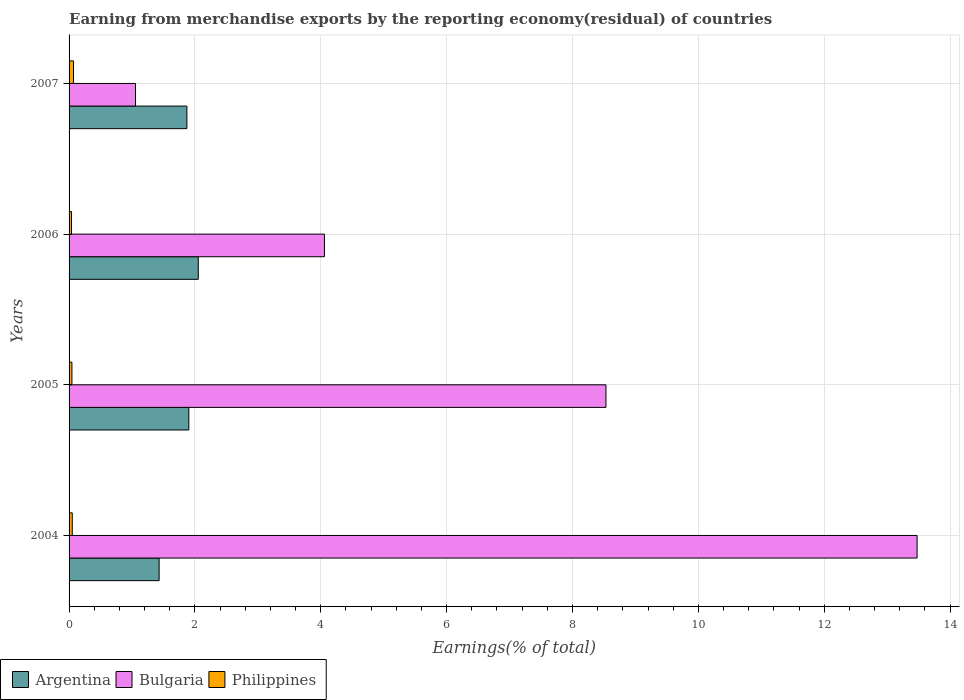How many different coloured bars are there?
Offer a terse response. 3. How many groups of bars are there?
Offer a terse response. 4. Are the number of bars on each tick of the Y-axis equal?
Keep it short and to the point. Yes. How many bars are there on the 2nd tick from the top?
Give a very brief answer. 3. How many bars are there on the 1st tick from the bottom?
Offer a terse response. 3. In how many cases, is the number of bars for a given year not equal to the number of legend labels?
Offer a terse response. 0. What is the percentage of amount earned from merchandise exports in Argentina in 2007?
Provide a short and direct response. 1.87. Across all years, what is the maximum percentage of amount earned from merchandise exports in Philippines?
Keep it short and to the point. 0.07. Across all years, what is the minimum percentage of amount earned from merchandise exports in Philippines?
Offer a terse response. 0.04. What is the total percentage of amount earned from merchandise exports in Argentina in the graph?
Your response must be concise. 7.26. What is the difference between the percentage of amount earned from merchandise exports in Philippines in 2004 and that in 2006?
Offer a terse response. 0.01. What is the difference between the percentage of amount earned from merchandise exports in Philippines in 2004 and the percentage of amount earned from merchandise exports in Argentina in 2005?
Ensure brevity in your answer.  -1.85. What is the average percentage of amount earned from merchandise exports in Argentina per year?
Your answer should be compact. 1.82. In the year 2007, what is the difference between the percentage of amount earned from merchandise exports in Philippines and percentage of amount earned from merchandise exports in Argentina?
Ensure brevity in your answer.  -1.8. In how many years, is the percentage of amount earned from merchandise exports in Argentina greater than 8.4 %?
Provide a short and direct response. 0. What is the ratio of the percentage of amount earned from merchandise exports in Philippines in 2006 to that in 2007?
Your answer should be very brief. 0.55. Is the percentage of amount earned from merchandise exports in Argentina in 2005 less than that in 2006?
Offer a very short reply. Yes. What is the difference between the highest and the second highest percentage of amount earned from merchandise exports in Philippines?
Your answer should be very brief. 0.02. What is the difference between the highest and the lowest percentage of amount earned from merchandise exports in Argentina?
Keep it short and to the point. 0.62. Is the sum of the percentage of amount earned from merchandise exports in Philippines in 2006 and 2007 greater than the maximum percentage of amount earned from merchandise exports in Bulgaria across all years?
Your response must be concise. No. What does the 1st bar from the top in 2007 represents?
Ensure brevity in your answer.  Philippines. What does the 2nd bar from the bottom in 2004 represents?
Keep it short and to the point. Bulgaria. Is it the case that in every year, the sum of the percentage of amount earned from merchandise exports in Argentina and percentage of amount earned from merchandise exports in Bulgaria is greater than the percentage of amount earned from merchandise exports in Philippines?
Ensure brevity in your answer.  Yes. How many bars are there?
Offer a very short reply. 12. Are all the bars in the graph horizontal?
Your answer should be very brief. Yes. Where does the legend appear in the graph?
Ensure brevity in your answer.  Bottom left. What is the title of the graph?
Keep it short and to the point. Earning from merchandise exports by the reporting economy(residual) of countries. Does "Comoros" appear as one of the legend labels in the graph?
Offer a terse response. No. What is the label or title of the X-axis?
Keep it short and to the point. Earnings(% of total). What is the label or title of the Y-axis?
Provide a succinct answer. Years. What is the Earnings(% of total) of Argentina in 2004?
Offer a terse response. 1.43. What is the Earnings(% of total) in Bulgaria in 2004?
Provide a short and direct response. 13.48. What is the Earnings(% of total) in Philippines in 2004?
Offer a very short reply. 0.05. What is the Earnings(% of total) in Argentina in 2005?
Your response must be concise. 1.9. What is the Earnings(% of total) of Bulgaria in 2005?
Provide a short and direct response. 8.53. What is the Earnings(% of total) of Philippines in 2005?
Your answer should be very brief. 0.05. What is the Earnings(% of total) of Argentina in 2006?
Offer a terse response. 2.05. What is the Earnings(% of total) in Bulgaria in 2006?
Your response must be concise. 4.06. What is the Earnings(% of total) in Philippines in 2006?
Ensure brevity in your answer.  0.04. What is the Earnings(% of total) in Argentina in 2007?
Provide a short and direct response. 1.87. What is the Earnings(% of total) of Bulgaria in 2007?
Your response must be concise. 1.06. What is the Earnings(% of total) in Philippines in 2007?
Your answer should be compact. 0.07. Across all years, what is the maximum Earnings(% of total) in Argentina?
Provide a succinct answer. 2.05. Across all years, what is the maximum Earnings(% of total) of Bulgaria?
Offer a very short reply. 13.48. Across all years, what is the maximum Earnings(% of total) in Philippines?
Your answer should be compact. 0.07. Across all years, what is the minimum Earnings(% of total) in Argentina?
Provide a succinct answer. 1.43. Across all years, what is the minimum Earnings(% of total) of Bulgaria?
Offer a very short reply. 1.06. Across all years, what is the minimum Earnings(% of total) of Philippines?
Offer a very short reply. 0.04. What is the total Earnings(% of total) in Argentina in the graph?
Your answer should be very brief. 7.26. What is the total Earnings(% of total) in Bulgaria in the graph?
Give a very brief answer. 27.12. What is the total Earnings(% of total) in Philippines in the graph?
Give a very brief answer. 0.21. What is the difference between the Earnings(% of total) in Argentina in 2004 and that in 2005?
Make the answer very short. -0.47. What is the difference between the Earnings(% of total) in Bulgaria in 2004 and that in 2005?
Your answer should be compact. 4.94. What is the difference between the Earnings(% of total) of Philippines in 2004 and that in 2005?
Give a very brief answer. 0.01. What is the difference between the Earnings(% of total) in Argentina in 2004 and that in 2006?
Provide a short and direct response. -0.62. What is the difference between the Earnings(% of total) of Bulgaria in 2004 and that in 2006?
Offer a terse response. 9.42. What is the difference between the Earnings(% of total) of Philippines in 2004 and that in 2006?
Make the answer very short. 0.01. What is the difference between the Earnings(% of total) in Argentina in 2004 and that in 2007?
Ensure brevity in your answer.  -0.44. What is the difference between the Earnings(% of total) in Bulgaria in 2004 and that in 2007?
Your answer should be very brief. 12.42. What is the difference between the Earnings(% of total) in Philippines in 2004 and that in 2007?
Ensure brevity in your answer.  -0.02. What is the difference between the Earnings(% of total) of Argentina in 2005 and that in 2006?
Make the answer very short. -0.15. What is the difference between the Earnings(% of total) in Bulgaria in 2005 and that in 2006?
Your answer should be very brief. 4.47. What is the difference between the Earnings(% of total) of Philippines in 2005 and that in 2006?
Provide a succinct answer. 0.01. What is the difference between the Earnings(% of total) in Argentina in 2005 and that in 2007?
Give a very brief answer. 0.03. What is the difference between the Earnings(% of total) of Bulgaria in 2005 and that in 2007?
Ensure brevity in your answer.  7.48. What is the difference between the Earnings(% of total) in Philippines in 2005 and that in 2007?
Give a very brief answer. -0.03. What is the difference between the Earnings(% of total) of Argentina in 2006 and that in 2007?
Provide a short and direct response. 0.18. What is the difference between the Earnings(% of total) in Bulgaria in 2006 and that in 2007?
Provide a succinct answer. 3. What is the difference between the Earnings(% of total) of Philippines in 2006 and that in 2007?
Your answer should be compact. -0.03. What is the difference between the Earnings(% of total) of Argentina in 2004 and the Earnings(% of total) of Bulgaria in 2005?
Offer a terse response. -7.1. What is the difference between the Earnings(% of total) of Argentina in 2004 and the Earnings(% of total) of Philippines in 2005?
Your answer should be very brief. 1.39. What is the difference between the Earnings(% of total) in Bulgaria in 2004 and the Earnings(% of total) in Philippines in 2005?
Make the answer very short. 13.43. What is the difference between the Earnings(% of total) in Argentina in 2004 and the Earnings(% of total) in Bulgaria in 2006?
Give a very brief answer. -2.63. What is the difference between the Earnings(% of total) in Argentina in 2004 and the Earnings(% of total) in Philippines in 2006?
Your answer should be compact. 1.39. What is the difference between the Earnings(% of total) in Bulgaria in 2004 and the Earnings(% of total) in Philippines in 2006?
Provide a succinct answer. 13.44. What is the difference between the Earnings(% of total) in Argentina in 2004 and the Earnings(% of total) in Bulgaria in 2007?
Keep it short and to the point. 0.38. What is the difference between the Earnings(% of total) in Argentina in 2004 and the Earnings(% of total) in Philippines in 2007?
Keep it short and to the point. 1.36. What is the difference between the Earnings(% of total) in Bulgaria in 2004 and the Earnings(% of total) in Philippines in 2007?
Give a very brief answer. 13.41. What is the difference between the Earnings(% of total) in Argentina in 2005 and the Earnings(% of total) in Bulgaria in 2006?
Ensure brevity in your answer.  -2.16. What is the difference between the Earnings(% of total) of Argentina in 2005 and the Earnings(% of total) of Philippines in 2006?
Keep it short and to the point. 1.86. What is the difference between the Earnings(% of total) in Bulgaria in 2005 and the Earnings(% of total) in Philippines in 2006?
Make the answer very short. 8.49. What is the difference between the Earnings(% of total) of Argentina in 2005 and the Earnings(% of total) of Bulgaria in 2007?
Offer a very short reply. 0.85. What is the difference between the Earnings(% of total) in Argentina in 2005 and the Earnings(% of total) in Philippines in 2007?
Your answer should be very brief. 1.83. What is the difference between the Earnings(% of total) of Bulgaria in 2005 and the Earnings(% of total) of Philippines in 2007?
Offer a very short reply. 8.46. What is the difference between the Earnings(% of total) in Argentina in 2006 and the Earnings(% of total) in Bulgaria in 2007?
Your response must be concise. 1. What is the difference between the Earnings(% of total) of Argentina in 2006 and the Earnings(% of total) of Philippines in 2007?
Offer a terse response. 1.98. What is the difference between the Earnings(% of total) of Bulgaria in 2006 and the Earnings(% of total) of Philippines in 2007?
Provide a short and direct response. 3.99. What is the average Earnings(% of total) of Argentina per year?
Your answer should be very brief. 1.81. What is the average Earnings(% of total) of Bulgaria per year?
Offer a very short reply. 6.78. What is the average Earnings(% of total) of Philippines per year?
Make the answer very short. 0.05. In the year 2004, what is the difference between the Earnings(% of total) in Argentina and Earnings(% of total) in Bulgaria?
Provide a succinct answer. -12.04. In the year 2004, what is the difference between the Earnings(% of total) of Argentina and Earnings(% of total) of Philippines?
Offer a terse response. 1.38. In the year 2004, what is the difference between the Earnings(% of total) in Bulgaria and Earnings(% of total) in Philippines?
Give a very brief answer. 13.43. In the year 2005, what is the difference between the Earnings(% of total) in Argentina and Earnings(% of total) in Bulgaria?
Ensure brevity in your answer.  -6.63. In the year 2005, what is the difference between the Earnings(% of total) of Argentina and Earnings(% of total) of Philippines?
Your response must be concise. 1.86. In the year 2005, what is the difference between the Earnings(% of total) of Bulgaria and Earnings(% of total) of Philippines?
Ensure brevity in your answer.  8.49. In the year 2006, what is the difference between the Earnings(% of total) of Argentina and Earnings(% of total) of Bulgaria?
Your answer should be very brief. -2. In the year 2006, what is the difference between the Earnings(% of total) in Argentina and Earnings(% of total) in Philippines?
Your answer should be very brief. 2.01. In the year 2006, what is the difference between the Earnings(% of total) of Bulgaria and Earnings(% of total) of Philippines?
Make the answer very short. 4.02. In the year 2007, what is the difference between the Earnings(% of total) in Argentina and Earnings(% of total) in Bulgaria?
Your answer should be compact. 0.82. In the year 2007, what is the difference between the Earnings(% of total) of Argentina and Earnings(% of total) of Philippines?
Your answer should be compact. 1.8. In the year 2007, what is the difference between the Earnings(% of total) of Bulgaria and Earnings(% of total) of Philippines?
Keep it short and to the point. 0.99. What is the ratio of the Earnings(% of total) of Argentina in 2004 to that in 2005?
Provide a short and direct response. 0.75. What is the ratio of the Earnings(% of total) of Bulgaria in 2004 to that in 2005?
Your answer should be very brief. 1.58. What is the ratio of the Earnings(% of total) in Philippines in 2004 to that in 2005?
Offer a terse response. 1.12. What is the ratio of the Earnings(% of total) of Argentina in 2004 to that in 2006?
Offer a terse response. 0.7. What is the ratio of the Earnings(% of total) of Bulgaria in 2004 to that in 2006?
Give a very brief answer. 3.32. What is the ratio of the Earnings(% of total) in Philippines in 2004 to that in 2006?
Ensure brevity in your answer.  1.3. What is the ratio of the Earnings(% of total) in Argentina in 2004 to that in 2007?
Ensure brevity in your answer.  0.76. What is the ratio of the Earnings(% of total) in Bulgaria in 2004 to that in 2007?
Give a very brief answer. 12.76. What is the ratio of the Earnings(% of total) of Philippines in 2004 to that in 2007?
Make the answer very short. 0.72. What is the ratio of the Earnings(% of total) of Argentina in 2005 to that in 2006?
Your response must be concise. 0.93. What is the ratio of the Earnings(% of total) in Bulgaria in 2005 to that in 2006?
Offer a terse response. 2.1. What is the ratio of the Earnings(% of total) of Philippines in 2005 to that in 2006?
Ensure brevity in your answer.  1.16. What is the ratio of the Earnings(% of total) in Argentina in 2005 to that in 2007?
Provide a short and direct response. 1.02. What is the ratio of the Earnings(% of total) of Bulgaria in 2005 to that in 2007?
Ensure brevity in your answer.  8.08. What is the ratio of the Earnings(% of total) in Philippines in 2005 to that in 2007?
Keep it short and to the point. 0.64. What is the ratio of the Earnings(% of total) in Argentina in 2006 to that in 2007?
Provide a succinct answer. 1.1. What is the ratio of the Earnings(% of total) in Bulgaria in 2006 to that in 2007?
Provide a succinct answer. 3.84. What is the ratio of the Earnings(% of total) of Philippines in 2006 to that in 2007?
Keep it short and to the point. 0.55. What is the difference between the highest and the second highest Earnings(% of total) of Argentina?
Your response must be concise. 0.15. What is the difference between the highest and the second highest Earnings(% of total) of Bulgaria?
Give a very brief answer. 4.94. What is the difference between the highest and the second highest Earnings(% of total) in Philippines?
Keep it short and to the point. 0.02. What is the difference between the highest and the lowest Earnings(% of total) of Argentina?
Ensure brevity in your answer.  0.62. What is the difference between the highest and the lowest Earnings(% of total) of Bulgaria?
Your answer should be compact. 12.42. What is the difference between the highest and the lowest Earnings(% of total) in Philippines?
Keep it short and to the point. 0.03. 